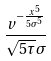<formula> <loc_0><loc_0><loc_500><loc_500>\frac { v ^ { - \frac { x ^ { 5 } } { 5 \sigma ^ { 5 } } } } { \sqrt { 5 \tau } \sigma }</formula> 